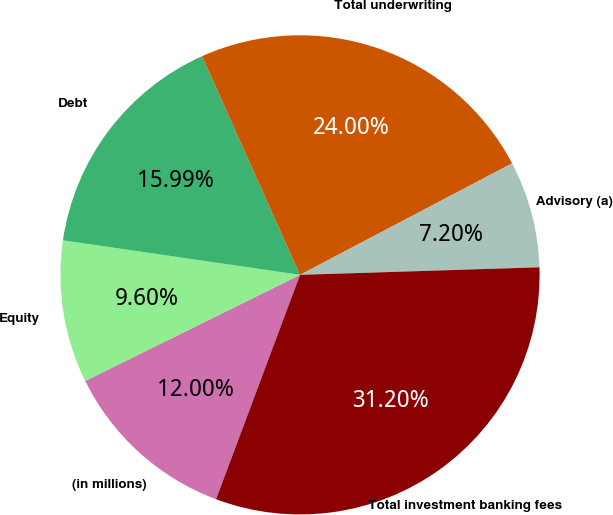Convert chart to OTSL. <chart><loc_0><loc_0><loc_500><loc_500><pie_chart><fcel>(in millions)<fcel>Equity<fcel>Debt<fcel>Total underwriting<fcel>Advisory (a)<fcel>Total investment banking fees<nl><fcel>12.0%<fcel>9.6%<fcel>15.99%<fcel>24.0%<fcel>7.2%<fcel>31.2%<nl></chart> 